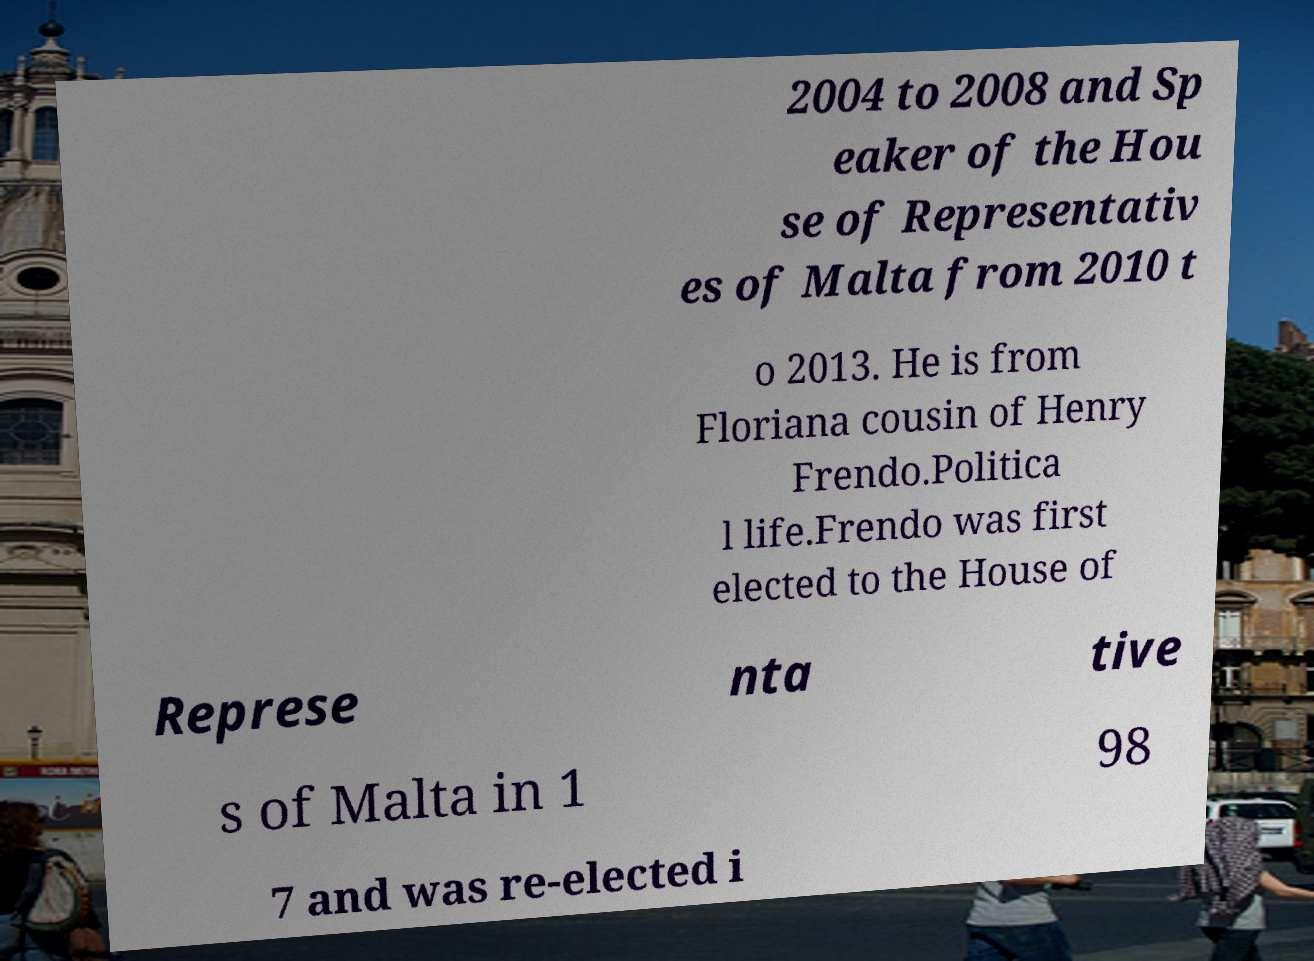I need the written content from this picture converted into text. Can you do that? 2004 to 2008 and Sp eaker of the Hou se of Representativ es of Malta from 2010 t o 2013. He is from Floriana cousin of Henry Frendo.Politica l life.Frendo was first elected to the House of Represe nta tive s of Malta in 1 98 7 and was re-elected i 